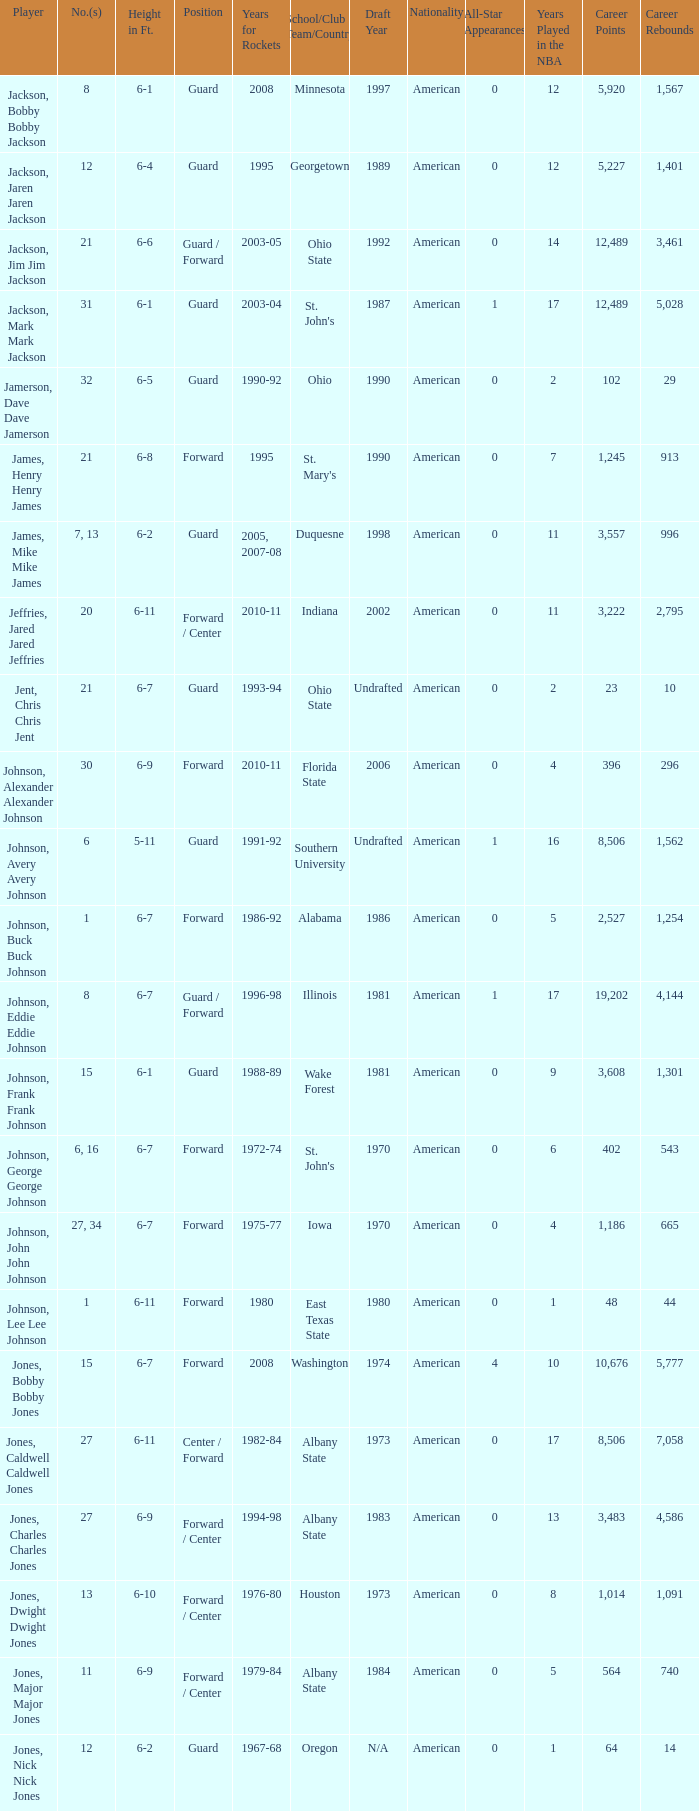Which athlete who competed for the rockets during the years 1986-92? Johnson, Buck Buck Johnson. 